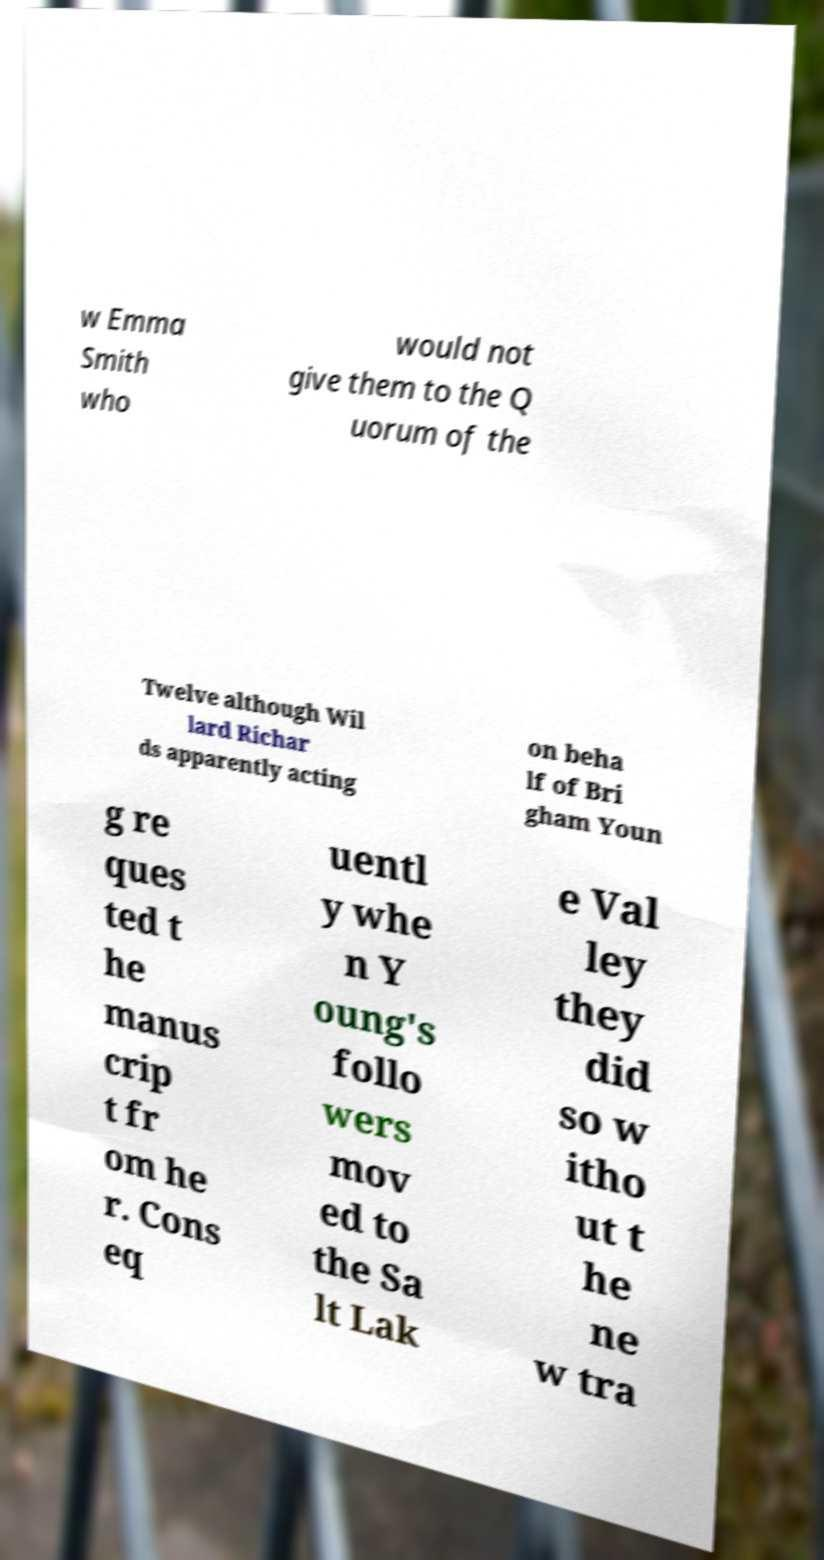Can you read and provide the text displayed in the image?This photo seems to have some interesting text. Can you extract and type it out for me? w Emma Smith who would not give them to the Q uorum of the Twelve although Wil lard Richar ds apparently acting on beha lf of Bri gham Youn g re ques ted t he manus crip t fr om he r. Cons eq uentl y whe n Y oung's follo wers mov ed to the Sa lt Lak e Val ley they did so w itho ut t he ne w tra 